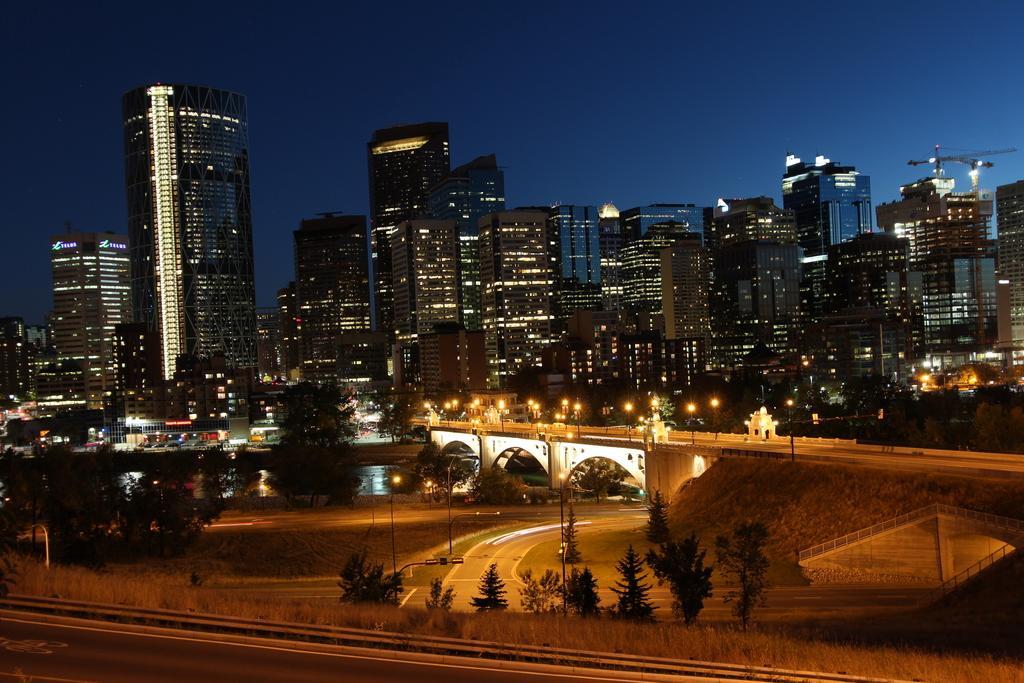In one or two sentences, can you explain what this image depicts? In this picture I can see at the bottom there are trees, in the middle there is a bridge and there are buildings with lights, at the top there is the sky. 